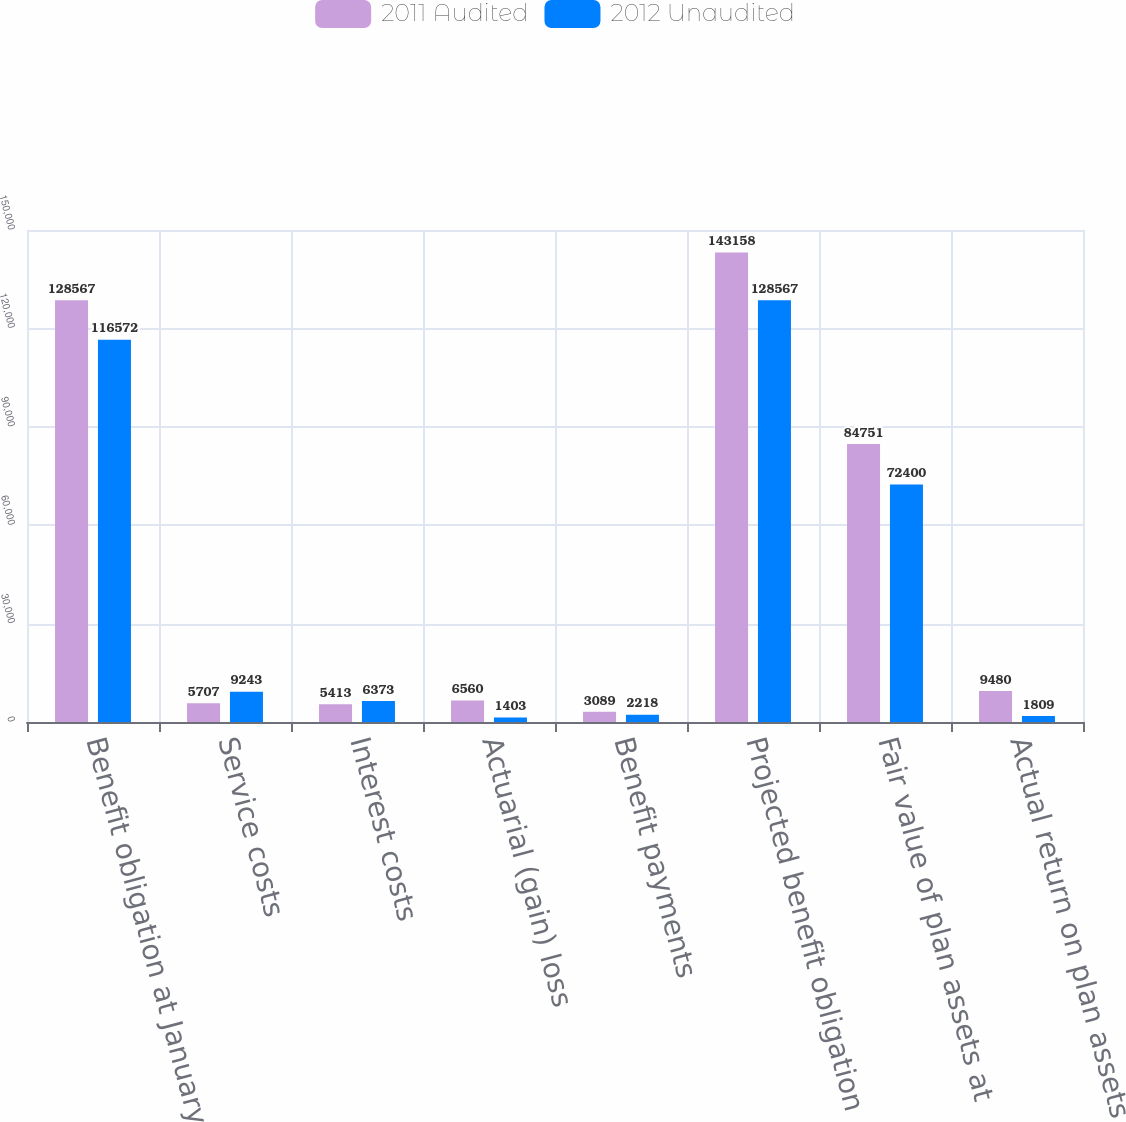Convert chart to OTSL. <chart><loc_0><loc_0><loc_500><loc_500><stacked_bar_chart><ecel><fcel>Benefit obligation at January<fcel>Service costs<fcel>Interest costs<fcel>Actuarial (gain) loss<fcel>Benefit payments<fcel>Projected benefit obligation<fcel>Fair value of plan assets at<fcel>Actual return on plan assets<nl><fcel>2011 Audited<fcel>128567<fcel>5707<fcel>5413<fcel>6560<fcel>3089<fcel>143158<fcel>84751<fcel>9480<nl><fcel>2012 Unaudited<fcel>116572<fcel>9243<fcel>6373<fcel>1403<fcel>2218<fcel>128567<fcel>72400<fcel>1809<nl></chart> 